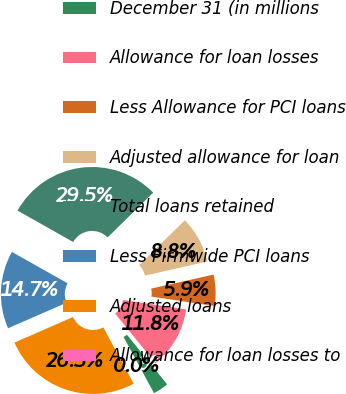Convert chart. <chart><loc_0><loc_0><loc_500><loc_500><pie_chart><fcel>December 31 (in millions<fcel>Allowance for loan losses<fcel>Less Allowance for PCI loans<fcel>Adjusted allowance for loan<fcel>Total loans retained<fcel>Less Firmwide PCI loans<fcel>Adjusted loans<fcel>Allowance for loan losses to<nl><fcel>2.95%<fcel>11.79%<fcel>5.89%<fcel>8.84%<fcel>29.47%<fcel>14.73%<fcel>26.34%<fcel>0.0%<nl></chart> 